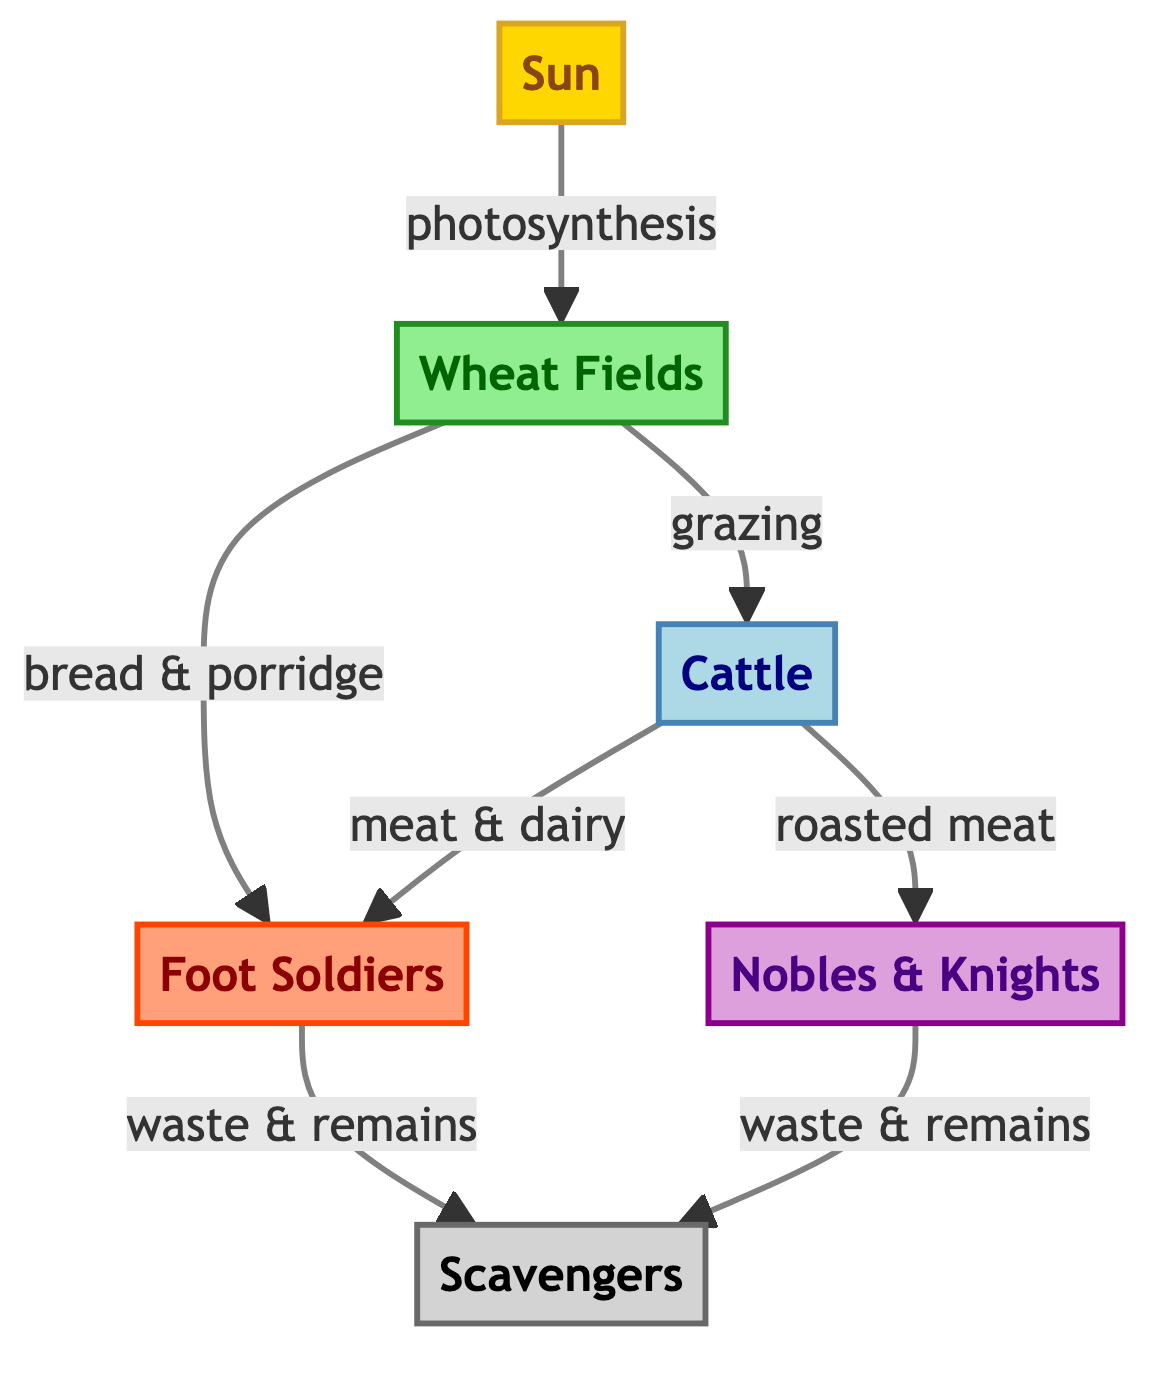How many primary producers are in the diagram? There is one primary producer shown in the diagram, which is the Wheat Fields. The count is derived from observing the nodes categorized under primary producers.
Answer: 1 What do Soldiers primarily consume besides wheat? Soldiers primarily consume meat and dairy from Cattle, as indicated by the connection from Cattle to Soldiers in the diagram.
Answer: meat & dairy Who are the tertiary consumers in this food chain? The Nobles & Knights are identified as the tertiary consumers in the diagram, which is based on the level of consumption they represent.
Answer: Nobles & Knights What do Scavengers feed on? Scavengers feed on the waste and remains of both Soldiers and Nobles, as indicated by the arrows pointing towards Scavengers from these two nodes in the diagram.
Answer: waste & remains What energy source initiates the food chain? The Sun is identified as the initial energy source that sustains the entire food chain, as depicted by the first node in the diagram.
Answer: Sun What relationship exists between Wheat and Cattle? The relationship between Wheat and Cattle is one of grazing; Cattle consume Wheat, as shown by the arrow connecting Wheat to Cattle.
Answer: grazing What is the primary food source for Foot Soldiers? The primary food source for Foot Soldiers includes both Wheat (in the form of bread & porridge) and Cattle (in the form of meat & dairy), as indicated by the connections in the diagram.
Answer: Wheat & Cattle Which node is classified as a decomposer? Scavengers are classified as a decomposer in the diagram, identified through the distinct color coding and connection to the waste from Soldiers and Nobles.
Answer: Scavengers How many arrows lead out from the Cattle node? There are two arrows leading out from the Cattle node indicating two types of consumption: one going to Soldiers for meat & dairy and one going to Nobles for roasted meat.
Answer: 2 